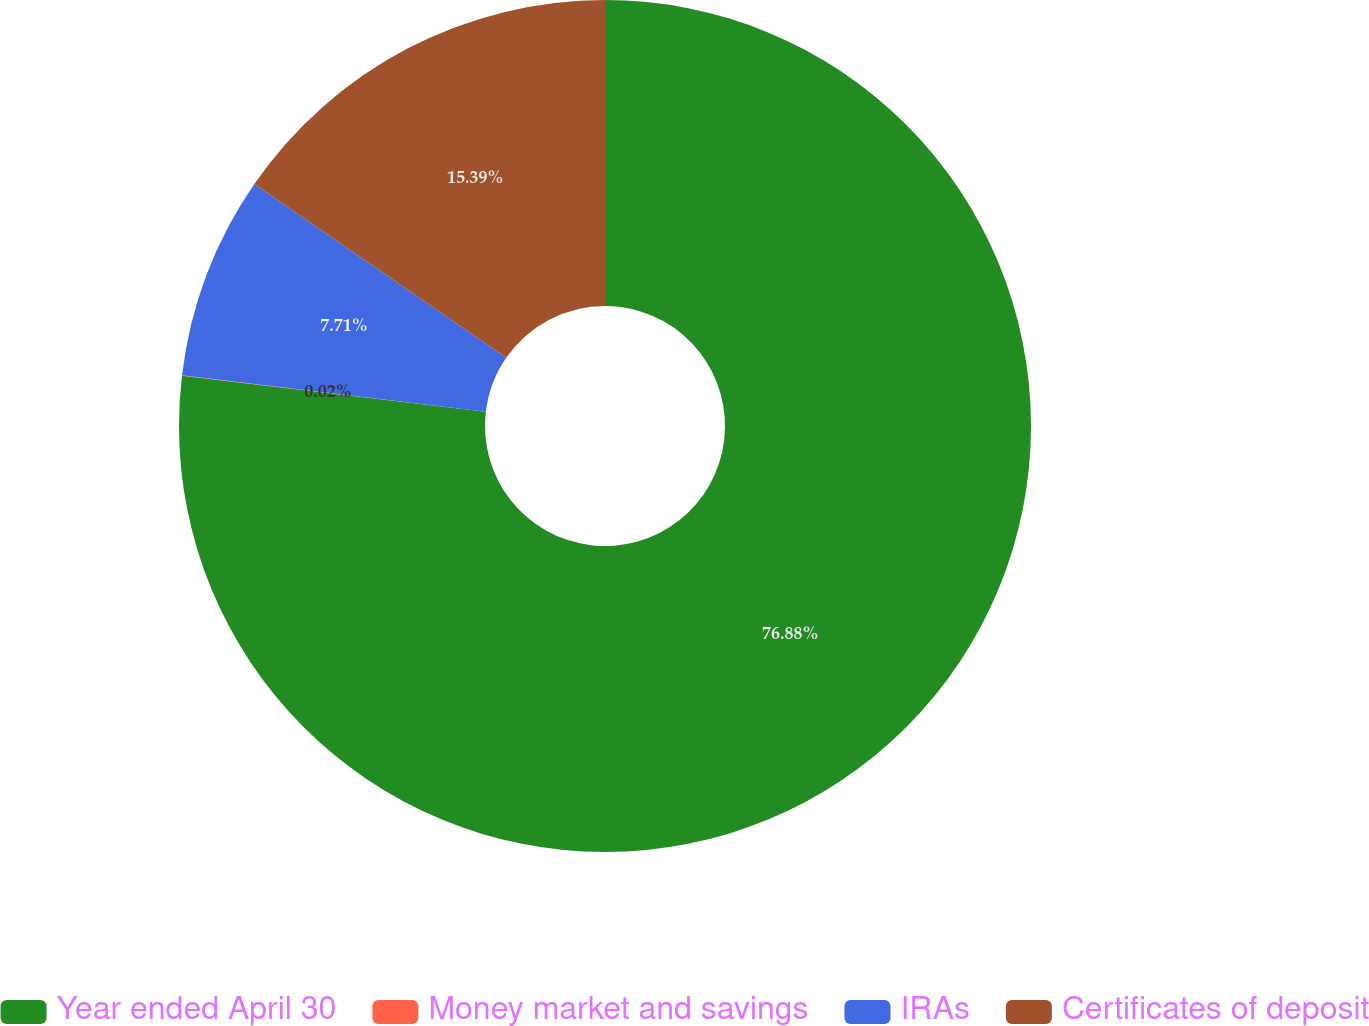Convert chart to OTSL. <chart><loc_0><loc_0><loc_500><loc_500><pie_chart><fcel>Year ended April 30<fcel>Money market and savings<fcel>IRAs<fcel>Certificates of deposit<nl><fcel>76.88%<fcel>0.02%<fcel>7.71%<fcel>15.39%<nl></chart> 